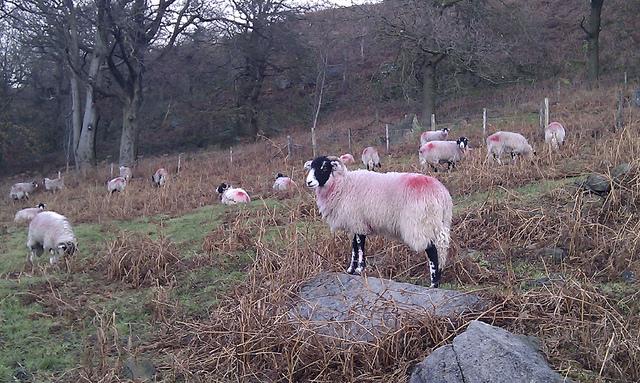How many sheep are in the picture?
Short answer required. 16. Why do these sheep have red markings on them?
Quick response, please. Identification. Have the sheep been shaved?
Give a very brief answer. No. How many types of livestock are shown?
Concise answer only. 1. What is written on the horses?
Answer briefly. No horses. 